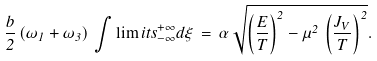<formula> <loc_0><loc_0><loc_500><loc_500>\frac { b } { 2 } \, ( \omega _ { 1 } + \omega _ { 3 } ) \, \int \lim i t s _ { - \infty } ^ { + \infty } d \xi \, = \, \alpha \, \sqrt { \left ( \frac { E } { T } \right ) ^ { 2 } - \mu ^ { 2 } \, \left ( \frac { J _ { V } } { T } \right ) ^ { 2 } } .</formula> 